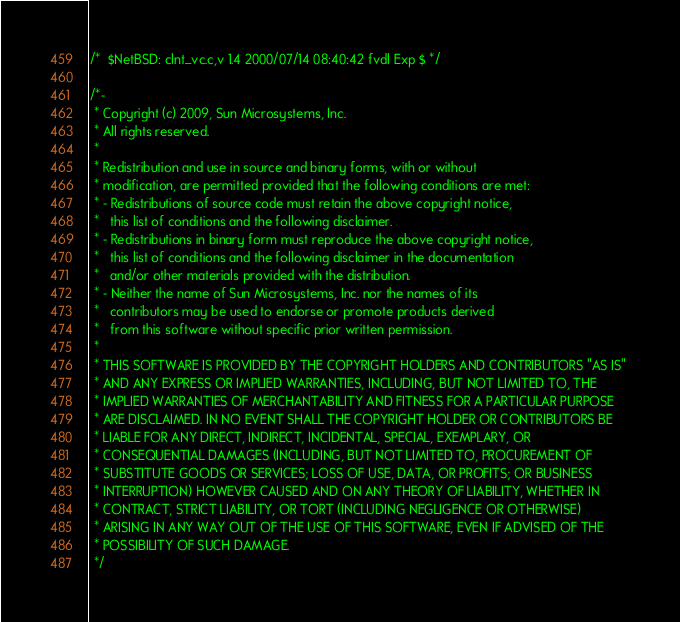Convert code to text. <code><loc_0><loc_0><loc_500><loc_500><_C_>/*	$NetBSD: clnt_vc.c,v 1.4 2000/07/14 08:40:42 fvdl Exp $	*/

/*-
 * Copyright (c) 2009, Sun Microsystems, Inc.
 * All rights reserved.
 *
 * Redistribution and use in source and binary forms, with or without 
 * modification, are permitted provided that the following conditions are met:
 * - Redistributions of source code must retain the above copyright notice, 
 *   this list of conditions and the following disclaimer.
 * - Redistributions in binary form must reproduce the above copyright notice, 
 *   this list of conditions and the following disclaimer in the documentation 
 *   and/or other materials provided with the distribution.
 * - Neither the name of Sun Microsystems, Inc. nor the names of its 
 *   contributors may be used to endorse or promote products derived 
 *   from this software without specific prior written permission.
 * 
 * THIS SOFTWARE IS PROVIDED BY THE COPYRIGHT HOLDERS AND CONTRIBUTORS "AS IS" 
 * AND ANY EXPRESS OR IMPLIED WARRANTIES, INCLUDING, BUT NOT LIMITED TO, THE 
 * IMPLIED WARRANTIES OF MERCHANTABILITY AND FITNESS FOR A PARTICULAR PURPOSE 
 * ARE DISCLAIMED. IN NO EVENT SHALL THE COPYRIGHT HOLDER OR CONTRIBUTORS BE 
 * LIABLE FOR ANY DIRECT, INDIRECT, INCIDENTAL, SPECIAL, EXEMPLARY, OR 
 * CONSEQUENTIAL DAMAGES (INCLUDING, BUT NOT LIMITED TO, PROCUREMENT OF 
 * SUBSTITUTE GOODS OR SERVICES; LOSS OF USE, DATA, OR PROFITS; OR BUSINESS 
 * INTERRUPTION) HOWEVER CAUSED AND ON ANY THEORY OF LIABILITY, WHETHER IN 
 * CONTRACT, STRICT LIABILITY, OR TORT (INCLUDING NEGLIGENCE OR OTHERWISE) 
 * ARISING IN ANY WAY OUT OF THE USE OF THIS SOFTWARE, EVEN IF ADVISED OF THE 
 * POSSIBILITY OF SUCH DAMAGE.
 */
</code> 